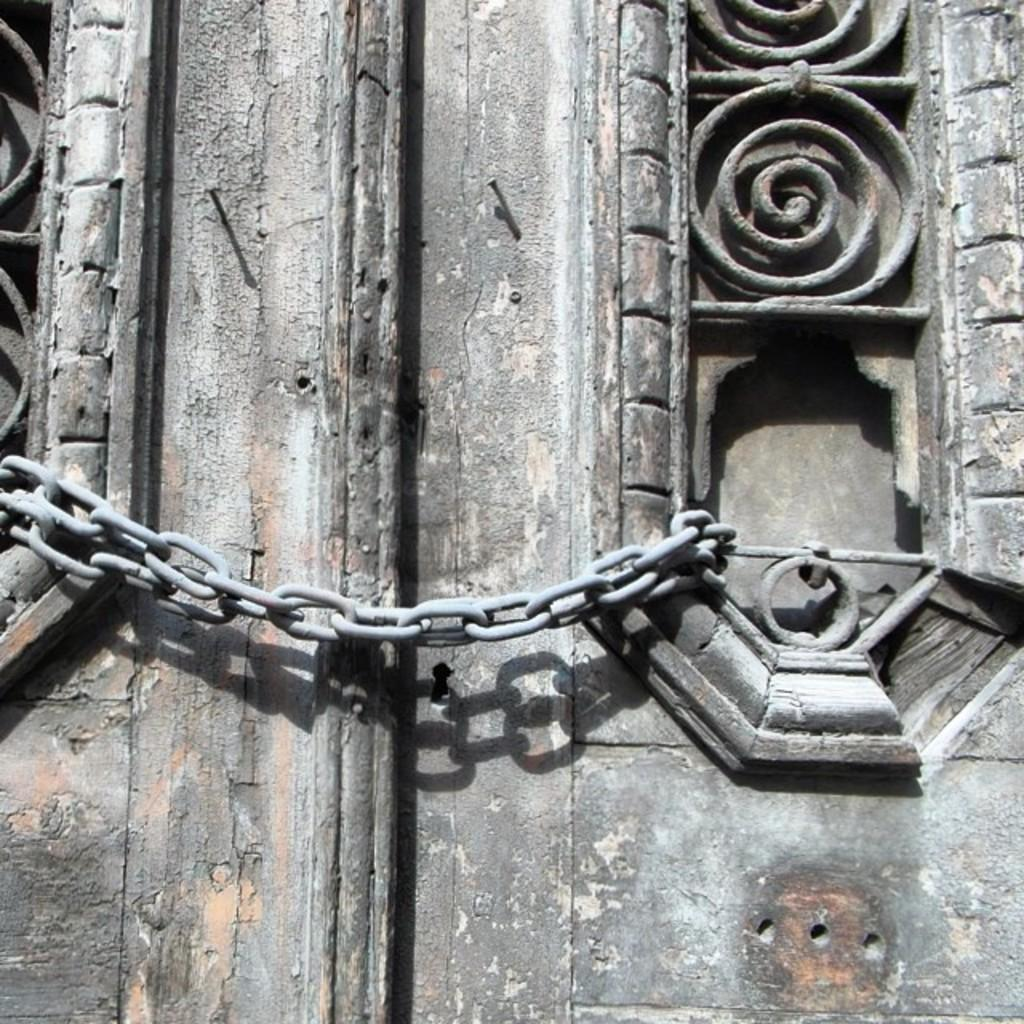What type of material is used for the objects in the image? The objects in the image are made of iron, specifically an iron chain and iron nails. What can be observed in relation to the objects in the image? Shadows are visible in the image. What type of pen can be seen in the image? There is no pen present in the image; it features an iron chain and iron nails. What kind of wave is visible in the image? There is no wave present in the image; it only contains an iron chain, iron nails, and shadows. 